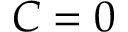Convert formula to latex. <formula><loc_0><loc_0><loc_500><loc_500>C = 0</formula> 